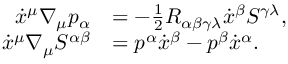<formula> <loc_0><loc_0><loc_500><loc_500>\begin{array} { r l } { \dot { x } ^ { \mu } \nabla _ { \mu } p _ { \alpha } } & { = - \frac { 1 } { 2 } R _ { \alpha \beta \gamma \lambda } \dot { x } ^ { \beta } S ^ { \gamma \lambda } , } \\ { \dot { x } ^ { \mu } \nabla _ { \mu } S ^ { \alpha \beta } } & { = p ^ { \alpha } \dot { x } ^ { \beta } - p ^ { \beta } \dot { x } ^ { \alpha } . } \end{array}</formula> 